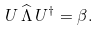Convert formula to latex. <formula><loc_0><loc_0><loc_500><loc_500>U \, \widehat { \Lambda } \, U ^ { \dagger } = \beta .</formula> 